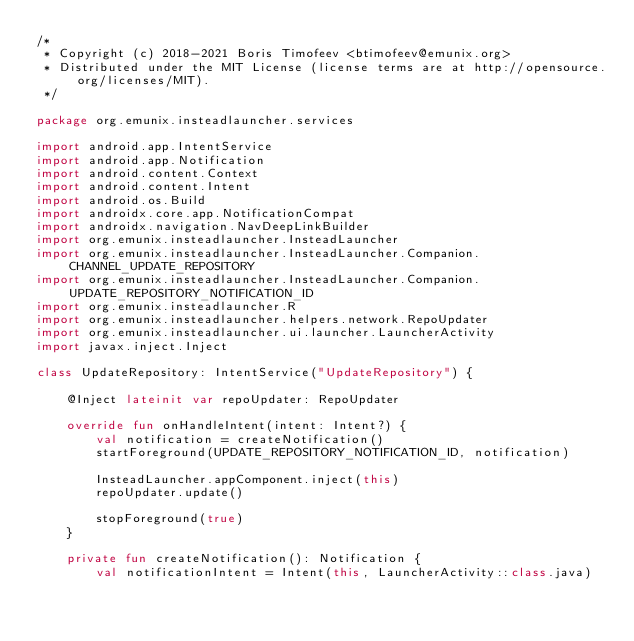Convert code to text. <code><loc_0><loc_0><loc_500><loc_500><_Kotlin_>/*
 * Copyright (c) 2018-2021 Boris Timofeev <btimofeev@emunix.org>
 * Distributed under the MIT License (license terms are at http://opensource.org/licenses/MIT).
 */

package org.emunix.insteadlauncher.services

import android.app.IntentService
import android.app.Notification
import android.content.Context
import android.content.Intent
import android.os.Build
import androidx.core.app.NotificationCompat
import androidx.navigation.NavDeepLinkBuilder
import org.emunix.insteadlauncher.InsteadLauncher
import org.emunix.insteadlauncher.InsteadLauncher.Companion.CHANNEL_UPDATE_REPOSITORY
import org.emunix.insteadlauncher.InsteadLauncher.Companion.UPDATE_REPOSITORY_NOTIFICATION_ID
import org.emunix.insteadlauncher.R
import org.emunix.insteadlauncher.helpers.network.RepoUpdater
import org.emunix.insteadlauncher.ui.launcher.LauncherActivity
import javax.inject.Inject

class UpdateRepository: IntentService("UpdateRepository") {

    @Inject lateinit var repoUpdater: RepoUpdater

    override fun onHandleIntent(intent: Intent?) {
        val notification = createNotification()
        startForeground(UPDATE_REPOSITORY_NOTIFICATION_ID, notification)

        InsteadLauncher.appComponent.inject(this)
        repoUpdater.update()

        stopForeground(true)
    }

    private fun createNotification(): Notification {
        val notificationIntent = Intent(this, LauncherActivity::class.java)</code> 